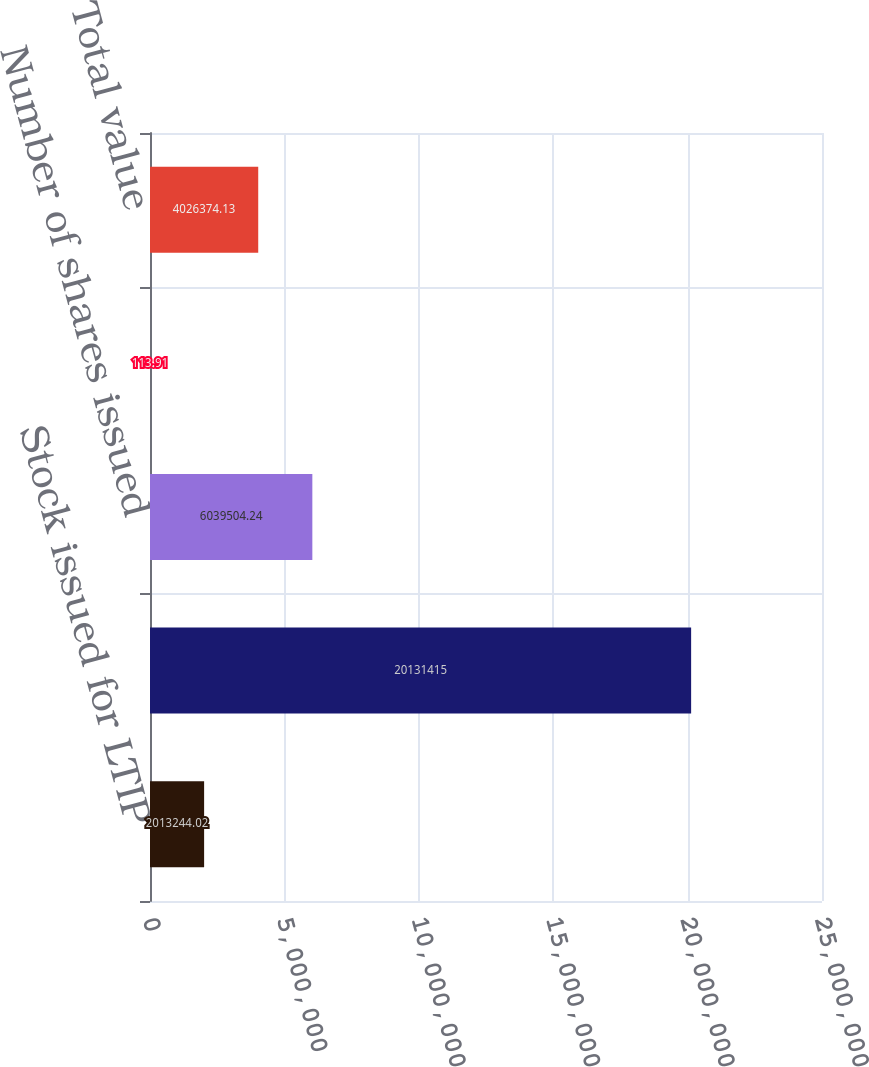Convert chart. <chart><loc_0><loc_0><loc_500><loc_500><bar_chart><fcel>Stock issued for LTIP<fcel>LTIP three-year plan<fcel>Number of shares issued<fcel>Share value on date of<fcel>Total value<nl><fcel>2.01324e+06<fcel>2.01314e+07<fcel>6.0395e+06<fcel>113.91<fcel>4.02637e+06<nl></chart> 